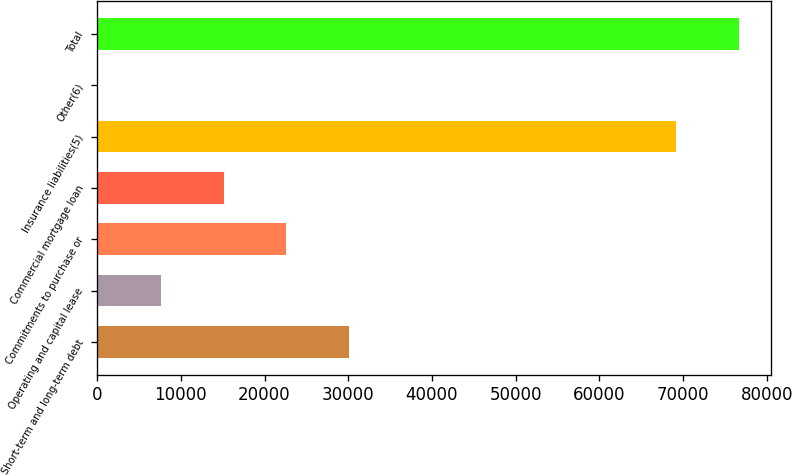Convert chart to OTSL. <chart><loc_0><loc_0><loc_500><loc_500><bar_chart><fcel>Short-term and long-term debt<fcel>Operating and capital lease<fcel>Commitments to purchase or<fcel>Commercial mortgage loan<fcel>Insurance liabilities(5)<fcel>Other(6)<fcel>Total<nl><fcel>30115.4<fcel>7592.6<fcel>22607.8<fcel>15100.2<fcel>69170<fcel>85<fcel>76677.6<nl></chart> 